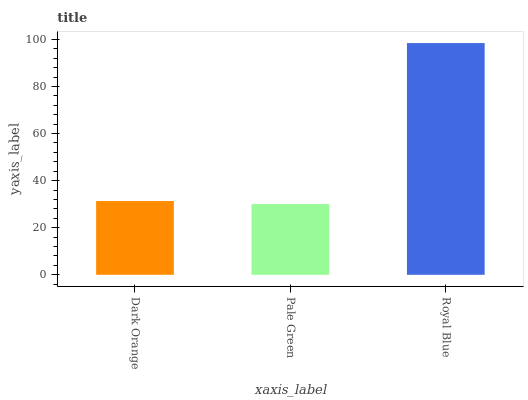Is Royal Blue the minimum?
Answer yes or no. No. Is Pale Green the maximum?
Answer yes or no. No. Is Royal Blue greater than Pale Green?
Answer yes or no. Yes. Is Pale Green less than Royal Blue?
Answer yes or no. Yes. Is Pale Green greater than Royal Blue?
Answer yes or no. No. Is Royal Blue less than Pale Green?
Answer yes or no. No. Is Dark Orange the high median?
Answer yes or no. Yes. Is Dark Orange the low median?
Answer yes or no. Yes. Is Royal Blue the high median?
Answer yes or no. No. Is Pale Green the low median?
Answer yes or no. No. 